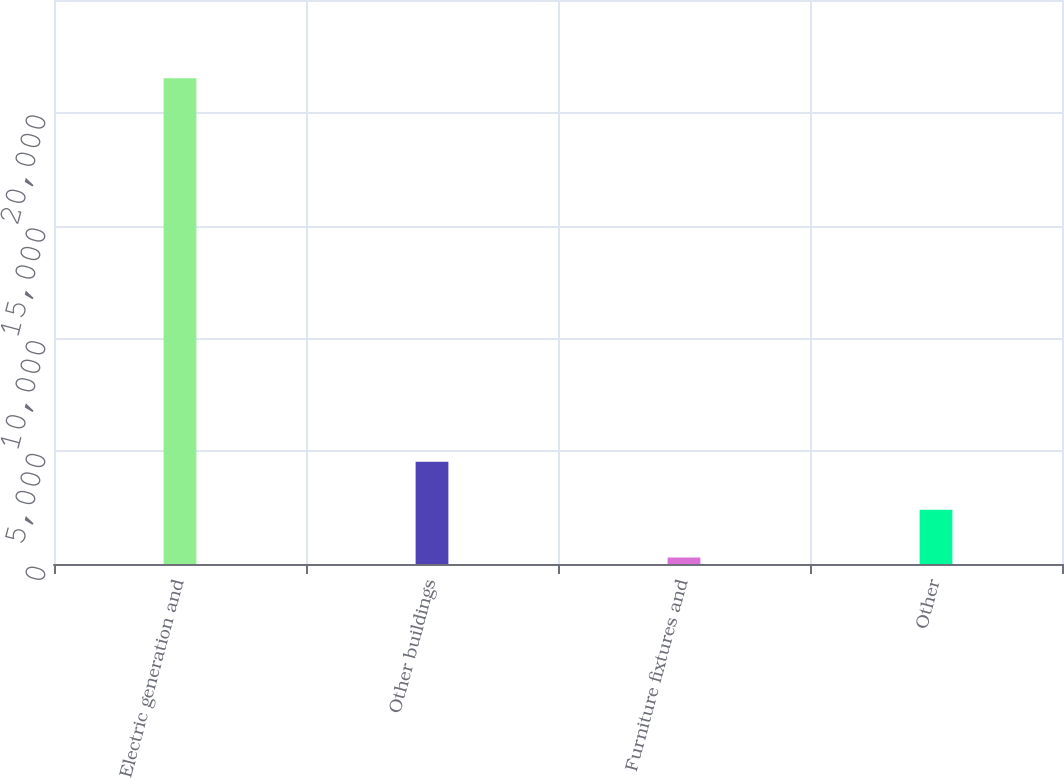Convert chart to OTSL. <chart><loc_0><loc_0><loc_500><loc_500><bar_chart><fcel>Electric generation and<fcel>Other buildings<fcel>Furniture fixtures and<fcel>Other<nl><fcel>21529<fcel>4533<fcel>284<fcel>2408.5<nl></chart> 